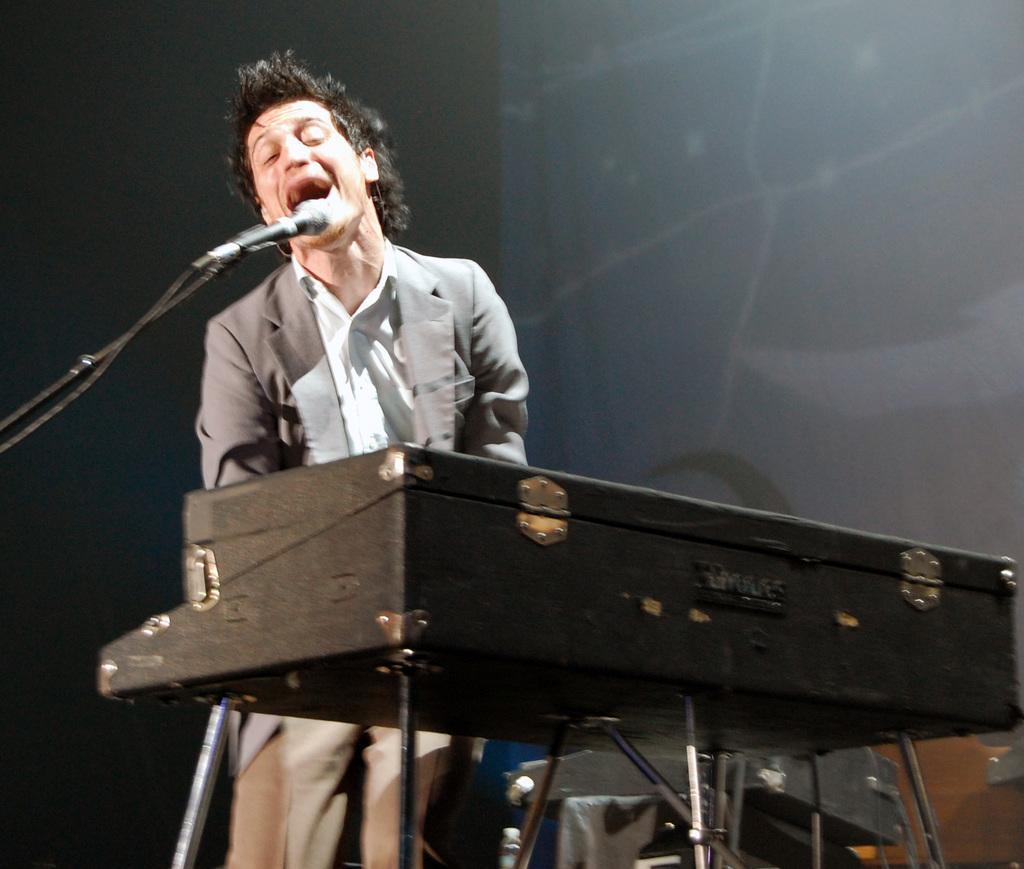How would you summarize this image in a sentence or two? There is a person singing. On the left side there is a mic with mic stand. Also there is a keyboard with stand. In the back there's a wall. 